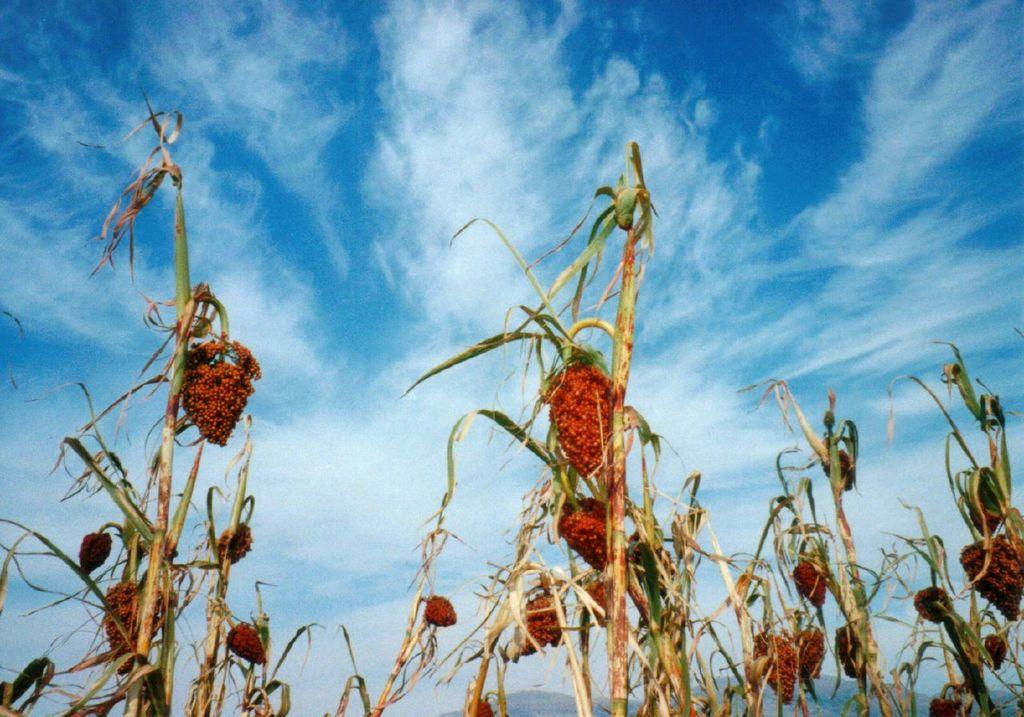What type of vegetation can be seen in the image? There are plants and flowers in the image. What is visible at the top of the image? The sky is visible at the top of the image. What can be observed in the sky? Clouds are present in the sky. What type of landscape feature is visible in the background of the image? There are mountains visible in the bottom background of the image. Where is the comb located in the image? There is no comb present in the image. What type of picture is hanging on the wall in the image? There is no picture hanging on the wall in the image. 